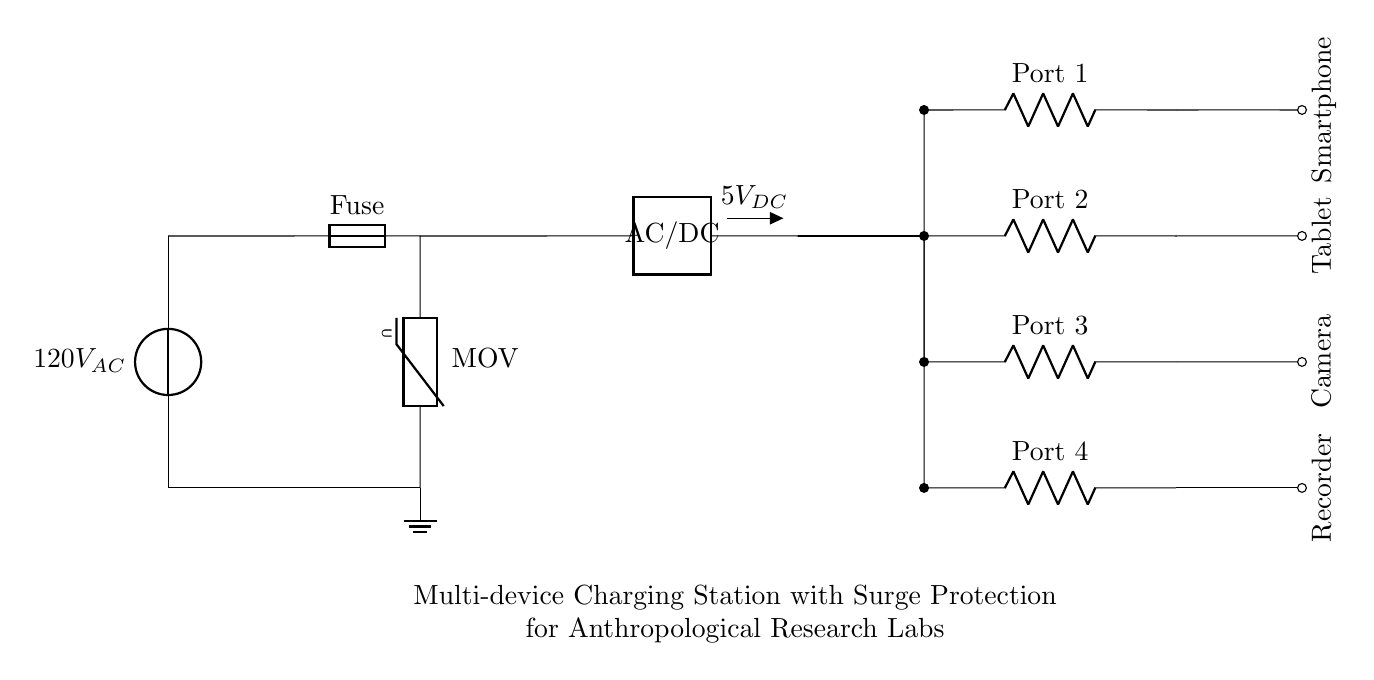What is the input voltage of the circuit? The input voltage is specified as 120V AC, which is indicated next to the power source symbol in the diagram.
Answer: 120V AC What type of component is used for surge protection? The surge protection in the circuit is provided by a metal oxide varistor (MOV), as indicated in the diagram right after the fuse component.
Answer: MOV How many USB charging ports are available? There are four USB charging ports depicted in the circuit. Each port is represented by a resistor labeled 'Port 1', 'Port 2', 'Port 3', and 'Port 4' on the right side of the diagram.
Answer: Four What is the output voltage for charging devices? The circuit's output voltage for charging devices is 5V DC, which is shown next to the AC/DC converter symbol in the diagram.
Answer: 5V DC Which devices are connected to the charging station? The devices connected are a smartphone, tablet, camera, and recorder, represented by labels next to the connections at the end of the circuit.
Answer: Smartphone, tablet, camera, recorder Which component limits current in this circuit? The fuse component is responsible for limiting current in the circuit, as it is designed to break the circuit if the current exceeds a certain level, preventing damage from surges.
Answer: Fuse What is the purpose of the AC/DC converter? The purpose of the AC/DC converter is to transform the input alternating current (AC) voltage from the power source into a direct current (DC) voltage suitable for charging devices, indicated in the diagram as converting to 5V DC.
Answer: To convert AC to DC 